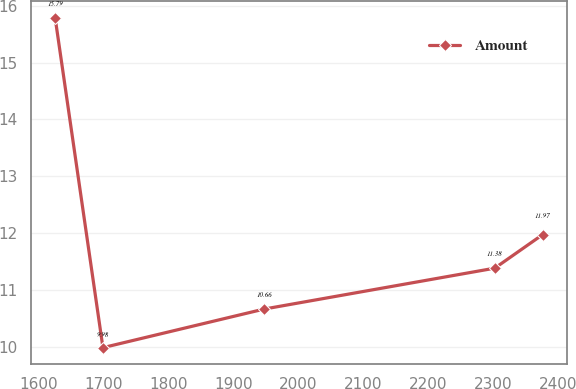<chart> <loc_0><loc_0><loc_500><loc_500><line_chart><ecel><fcel>Amount<nl><fcel>1624.7<fcel>15.79<nl><fcel>1698.4<fcel>9.98<nl><fcel>1947.05<fcel>10.66<nl><fcel>2302.5<fcel>11.38<nl><fcel>2376.2<fcel>11.97<nl></chart> 